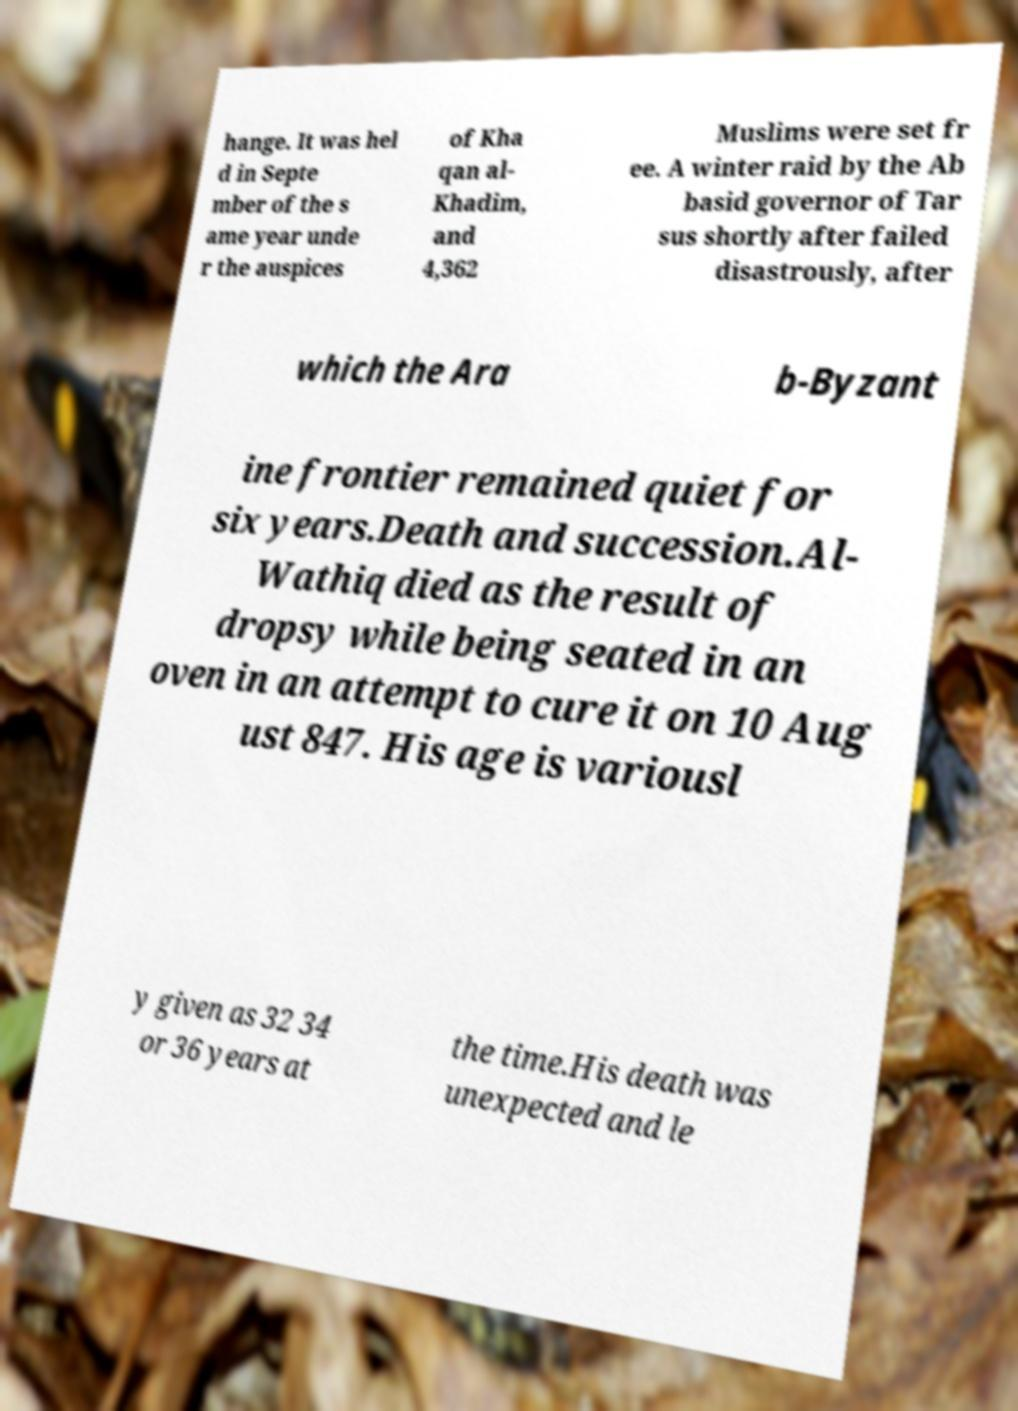Please identify and transcribe the text found in this image. hange. It was hel d in Septe mber of the s ame year unde r the auspices of Kha qan al- Khadim, and 4,362 Muslims were set fr ee. A winter raid by the Ab basid governor of Tar sus shortly after failed disastrously, after which the Ara b-Byzant ine frontier remained quiet for six years.Death and succession.Al- Wathiq died as the result of dropsy while being seated in an oven in an attempt to cure it on 10 Aug ust 847. His age is variousl y given as 32 34 or 36 years at the time.His death was unexpected and le 